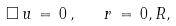Convert formula to latex. <formula><loc_0><loc_0><loc_500><loc_500>\Box \, { u } \, = \, 0 \, { , } \quad r \, = \, 0 , R ,</formula> 